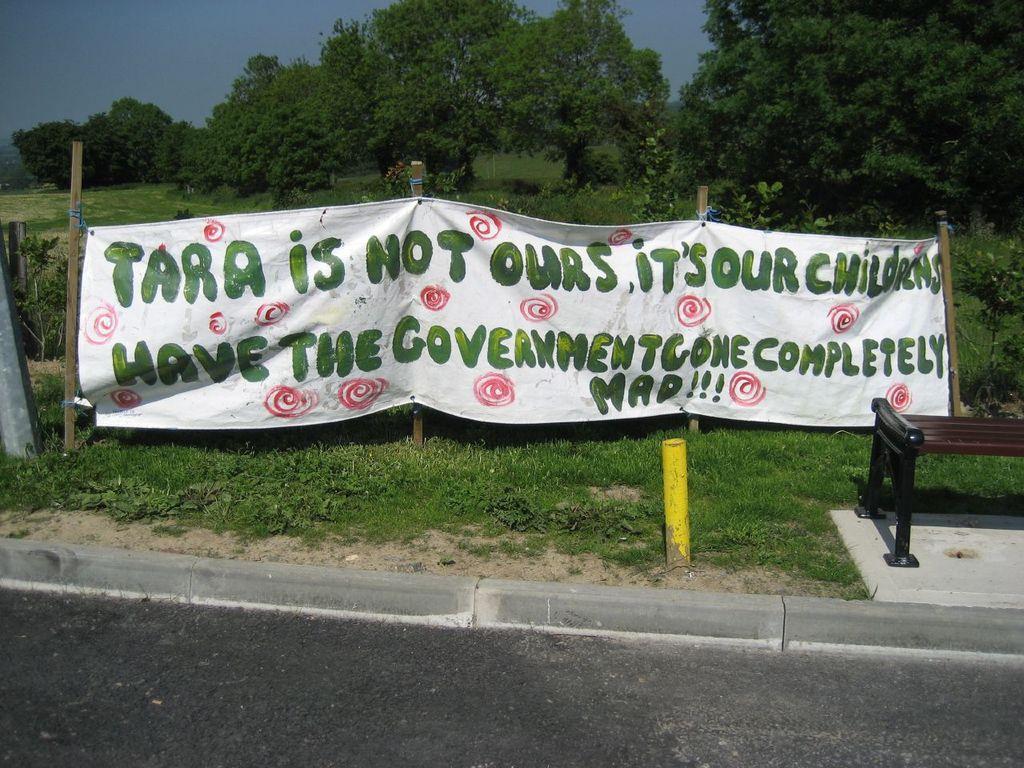Can you describe this image briefly? In the image we can see there is a banner kept on the ground and the ground is covered with grass. Behind there are trees and there is a bench on the ground. 